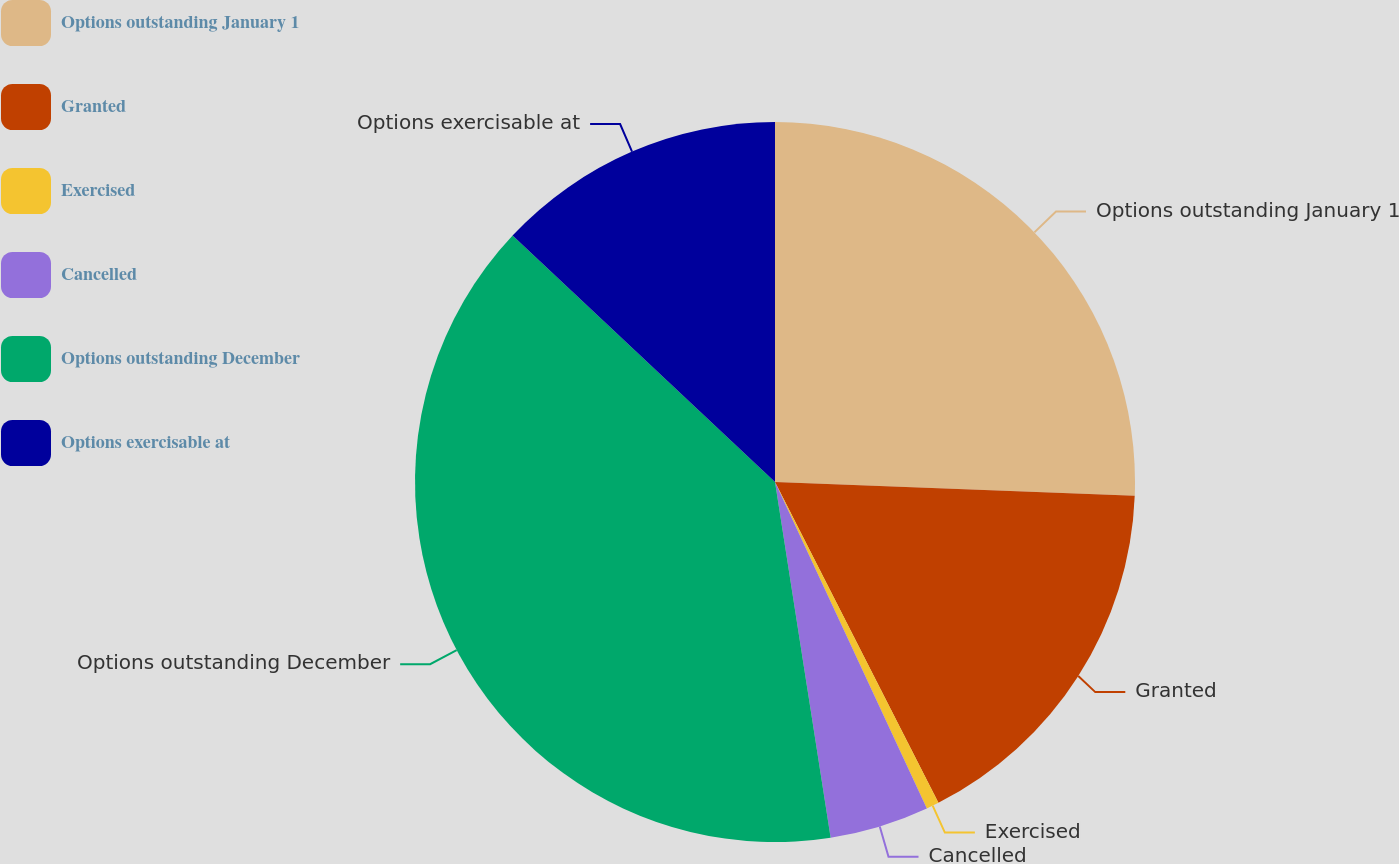Convert chart to OTSL. <chart><loc_0><loc_0><loc_500><loc_500><pie_chart><fcel>Options outstanding January 1<fcel>Granted<fcel>Exercised<fcel>Cancelled<fcel>Options outstanding December<fcel>Options exercisable at<nl><fcel>25.61%<fcel>16.89%<fcel>0.57%<fcel>4.46%<fcel>39.47%<fcel>13.0%<nl></chart> 